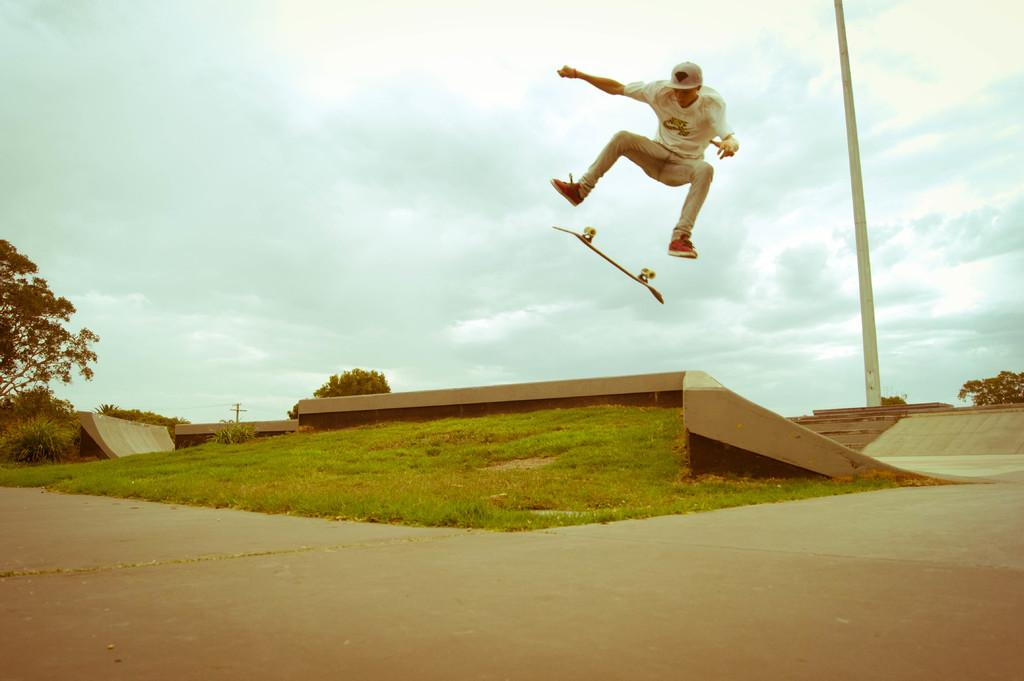What is the person in the image doing? The person is skating with a skateboard in the image. What type of surface can be seen in the image? There is a road in the image. What type of vegetation is present in the image? There is grass and trees in the image. What is attached to the utility pole in the image? There are wires attached to the utility pole in the image. What is visible in the sky in the image? The sky is visible in the image and appears cloudy. What type of produce is being sold at the roadside stand in the image? There is no roadside stand or produce present in the image. What is the person's chin doing in the image? There is no specific focus on the person's chin in the image. 